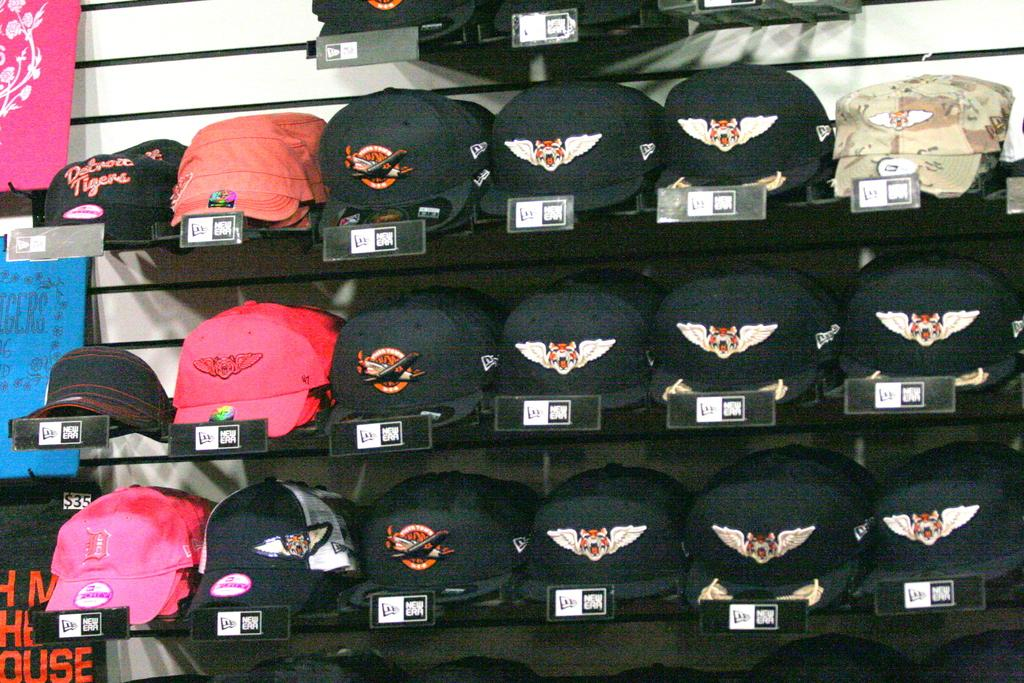What can be seen in the foreground of the image? There are different colored caps in the foreground of the image. How are the caps arranged in the image? The caps are in a rack. Are there any additional details about the caps in the image? Price tags are attached to the rack. What can be seen in the background of the image? There is a wall in the background of the image. What is hanging on the wall in the background? There are bags hanging on the wall in the background. What type of plants are being used for authority in the image? There are no plants or any indication of authority present in the image. 